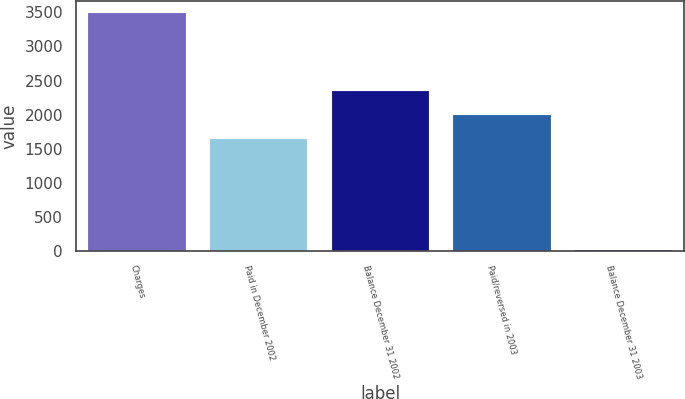Convert chart. <chart><loc_0><loc_0><loc_500><loc_500><bar_chart><fcel>Charges<fcel>Paid in December 2002<fcel>Balance December 31 2002<fcel>Paid/reversed in 2003<fcel>Balance December 31 2003<nl><fcel>3492<fcel>1643<fcel>2339.8<fcel>1991.4<fcel>8<nl></chart> 